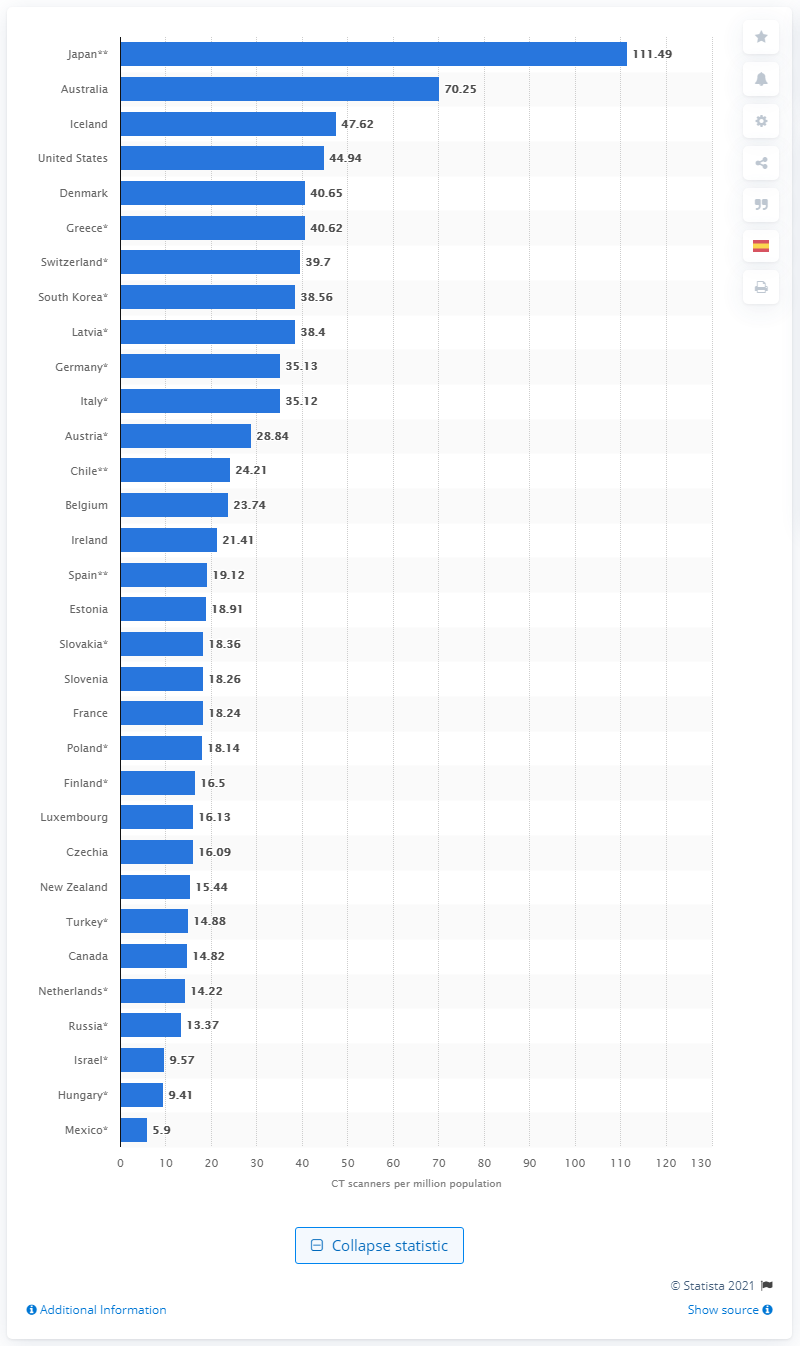Give some essential details in this illustration. Australia had the second highest number of scanners in the country. In 2019, Japan had approximately 111.49 CT scanners per million people, indicating a high level of access to diagnostic imaging technology. 